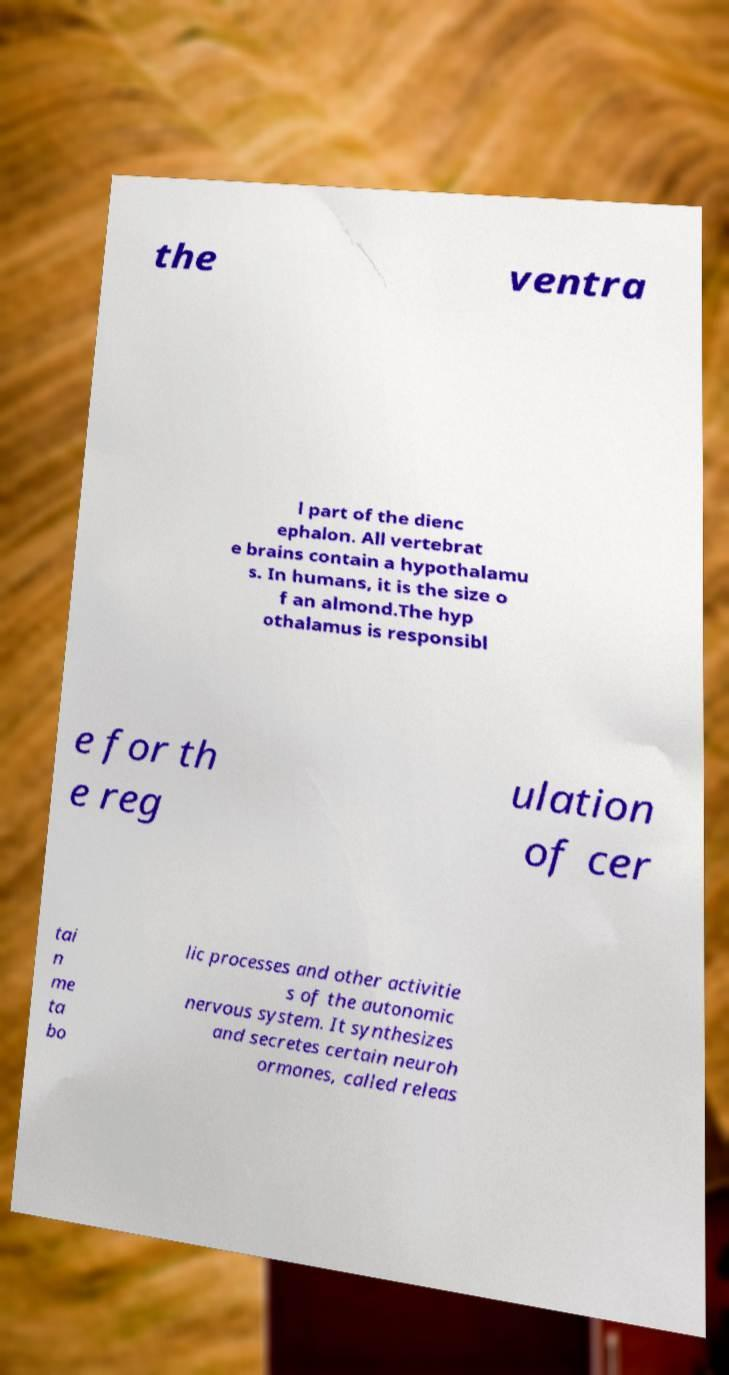Please read and relay the text visible in this image. What does it say? the ventra l part of the dienc ephalon. All vertebrat e brains contain a hypothalamu s. In humans, it is the size o f an almond.The hyp othalamus is responsibl e for th e reg ulation of cer tai n me ta bo lic processes and other activitie s of the autonomic nervous system. It synthesizes and secretes certain neuroh ormones, called releas 